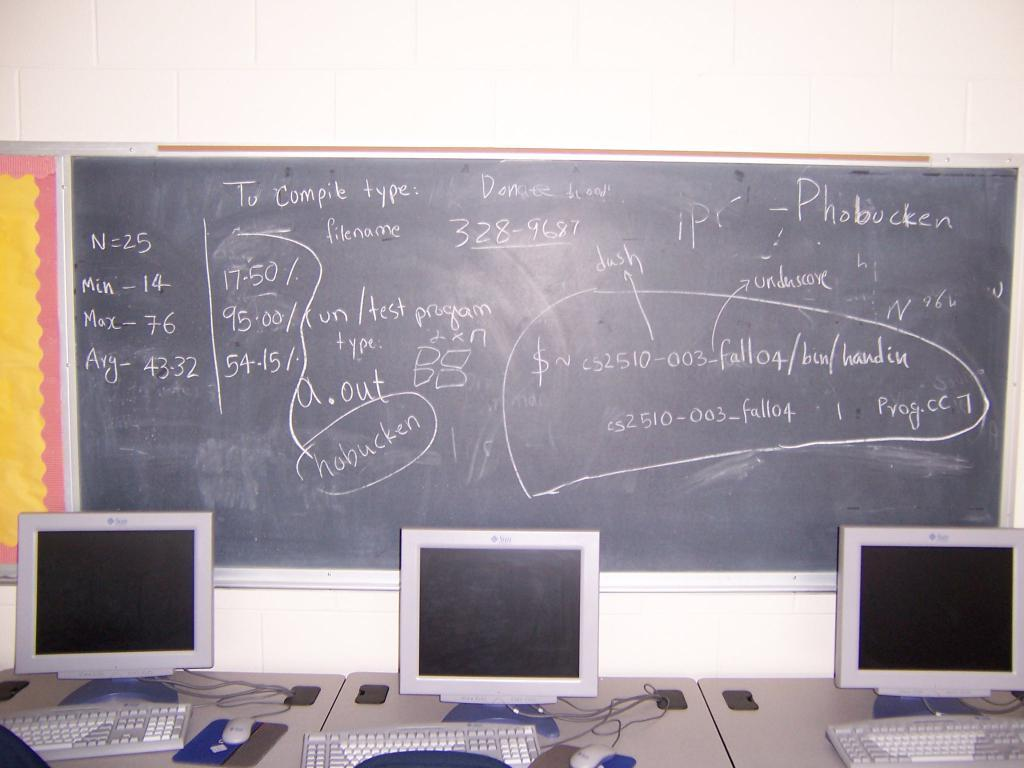<image>
Render a clear and concise summary of the photo. A chalkboard says N equals 25 and the minimum is 14. 